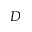Convert formula to latex. <formula><loc_0><loc_0><loc_500><loc_500>D</formula> 